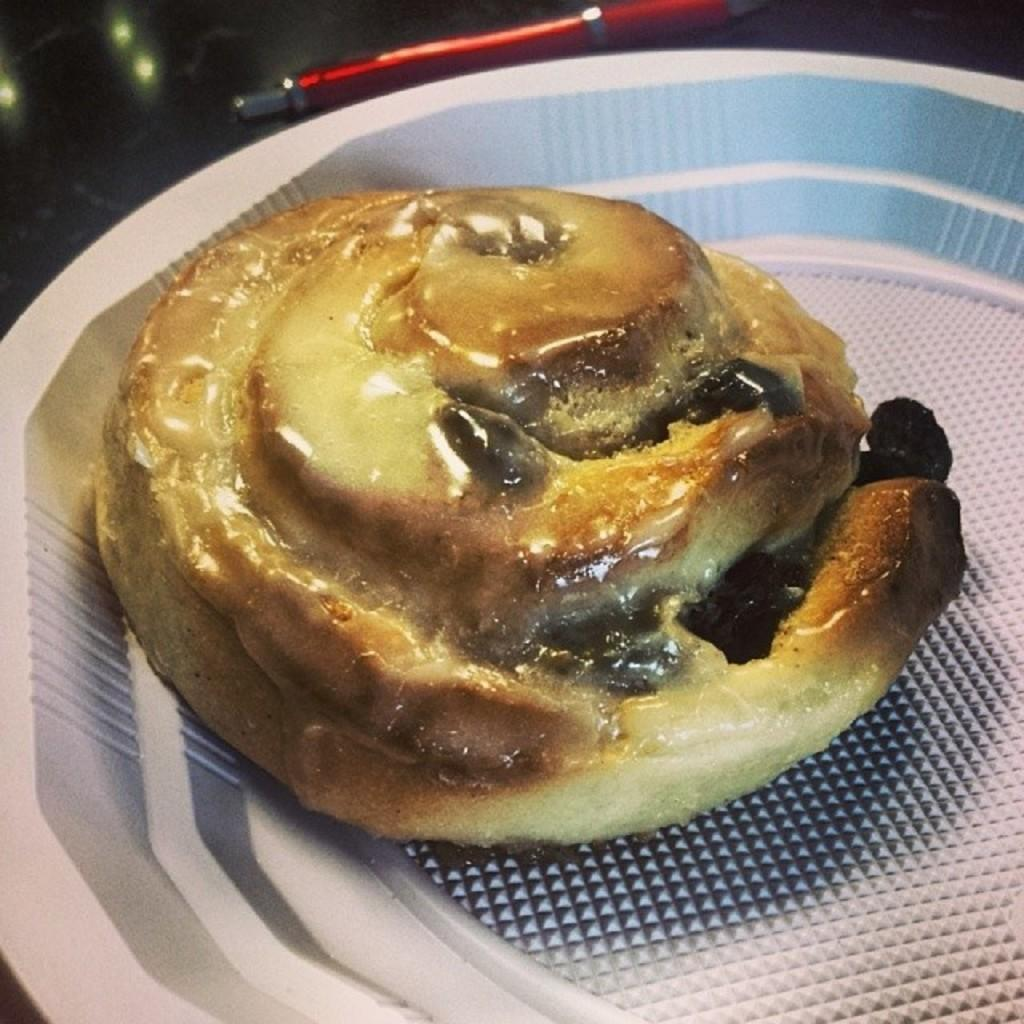What type of food can be seen in the image? There is cooked food in the image. How is the cooked food presented in the image? The cooked food is served on a plate. What type of band is playing in the background of the image? There is no band present in the image; it only features cooked food served on a plate. 